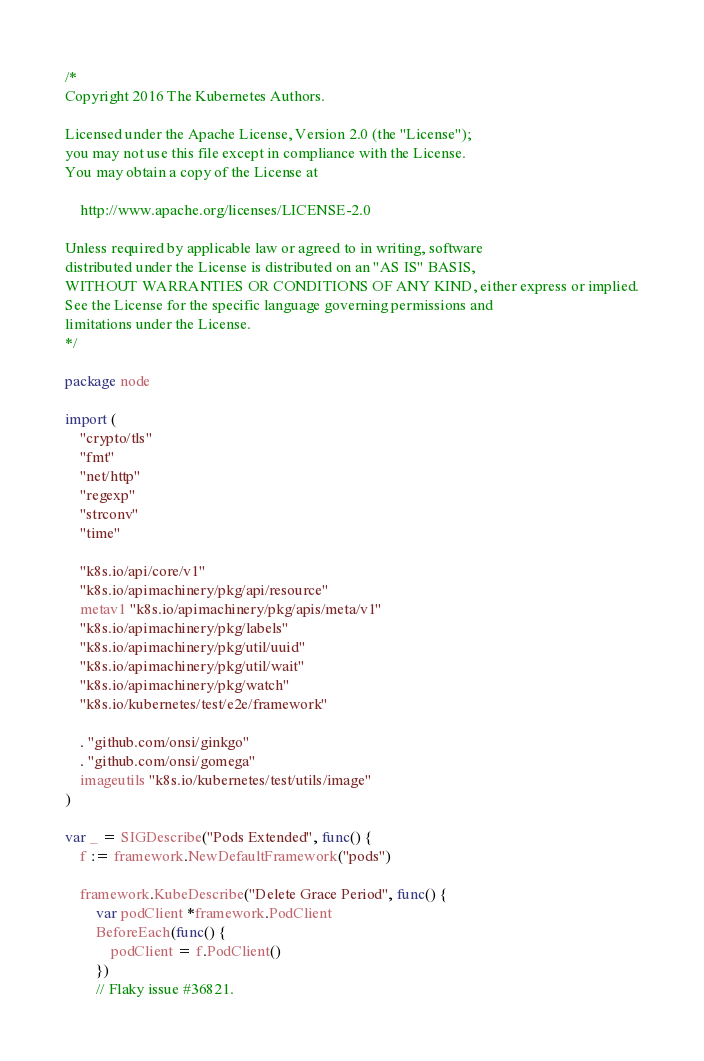Convert code to text. <code><loc_0><loc_0><loc_500><loc_500><_Go_>/*
Copyright 2016 The Kubernetes Authors.

Licensed under the Apache License, Version 2.0 (the "License");
you may not use this file except in compliance with the License.
You may obtain a copy of the License at

    http://www.apache.org/licenses/LICENSE-2.0

Unless required by applicable law or agreed to in writing, software
distributed under the License is distributed on an "AS IS" BASIS,
WITHOUT WARRANTIES OR CONDITIONS OF ANY KIND, either express or implied.
See the License for the specific language governing permissions and
limitations under the License.
*/

package node

import (
	"crypto/tls"
	"fmt"
	"net/http"
	"regexp"
	"strconv"
	"time"

	"k8s.io/api/core/v1"
	"k8s.io/apimachinery/pkg/api/resource"
	metav1 "k8s.io/apimachinery/pkg/apis/meta/v1"
	"k8s.io/apimachinery/pkg/labels"
	"k8s.io/apimachinery/pkg/util/uuid"
	"k8s.io/apimachinery/pkg/util/wait"
	"k8s.io/apimachinery/pkg/watch"
	"k8s.io/kubernetes/test/e2e/framework"

	. "github.com/onsi/ginkgo"
	. "github.com/onsi/gomega"
	imageutils "k8s.io/kubernetes/test/utils/image"
)

var _ = SIGDescribe("Pods Extended", func() {
	f := framework.NewDefaultFramework("pods")

	framework.KubeDescribe("Delete Grace Period", func() {
		var podClient *framework.PodClient
		BeforeEach(func() {
			podClient = f.PodClient()
		})
		// Flaky issue #36821.</code> 